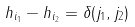Convert formula to latex. <formula><loc_0><loc_0><loc_500><loc_500>h _ { i _ { 1 } } - h _ { i _ { 2 } } = \delta ( j _ { 1 } , j _ { 2 } )</formula> 